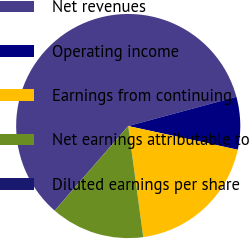Convert chart to OTSL. <chart><loc_0><loc_0><loc_500><loc_500><pie_chart><fcel>Net revenues<fcel>Operating income<fcel>Earnings from continuing<fcel>Net earnings attributable to<fcel>Diluted earnings per share<nl><fcel>59.41%<fcel>7.59%<fcel>19.47%<fcel>13.53%<fcel>0.01%<nl></chart> 